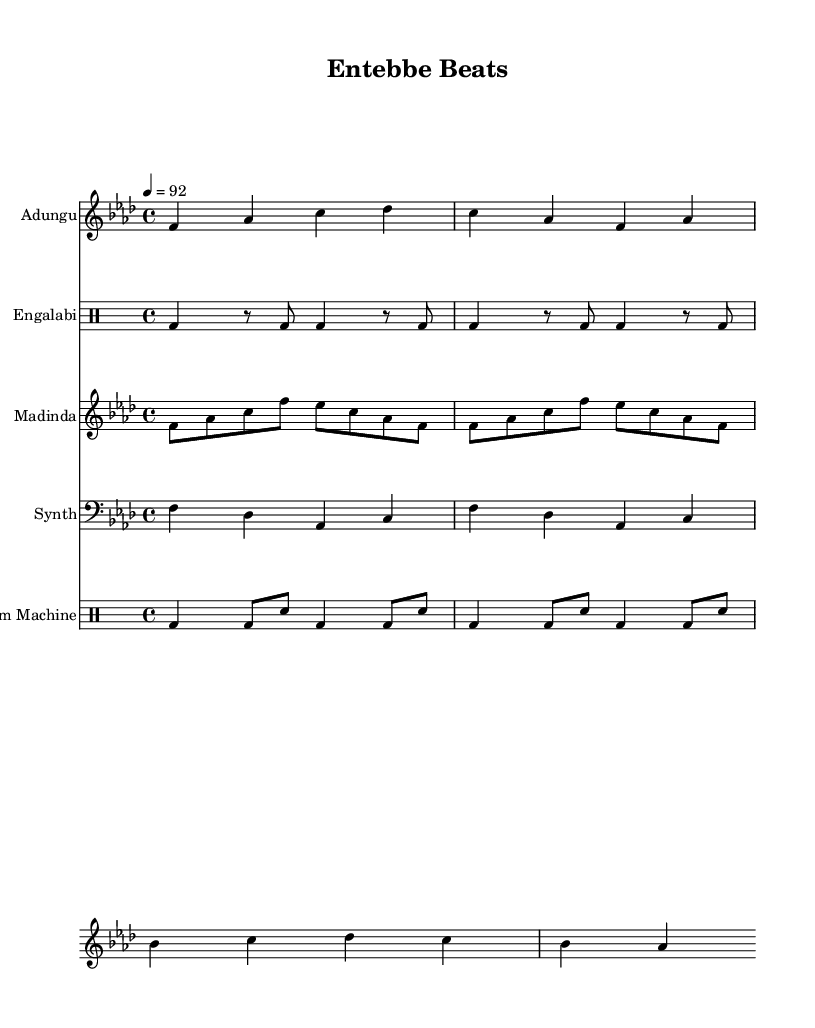What is the key signature of this music? The key signature is F minor, which is indicated by four flats on the staff.
Answer: F minor What is the time signature of this music? The time signature is 4/4, which is typically shown at the beginning of the sheet music.
Answer: 4/4 What is the tempo marking for this piece? The tempo is marked as 4 equals 92, indicating the beats per minute for the performance.
Answer: 92 How many measures are in the Adungu section? The Adungu section has four measures, counting the distinct sets of notes between the bar lines.
Answer: 4 In what clef is the Madinda section written? The Madinda section is written in treble clef, which is indicated at the beginning of its staff.
Answer: Treble Which instruments are classified as percussion in this sheet music? The percussion instruments include the Engalabi and Drum Machine, which are both in separate drum staff sections.
Answer: Engalabi, Drum Machine What traditional rhythms are incorporated in this Hip Hop fusion? The traditional rhythms are represented by the Engalabi and Madinda parts, which reflect Ugandan musical elements.
Answer: Engalabi, Madinda 